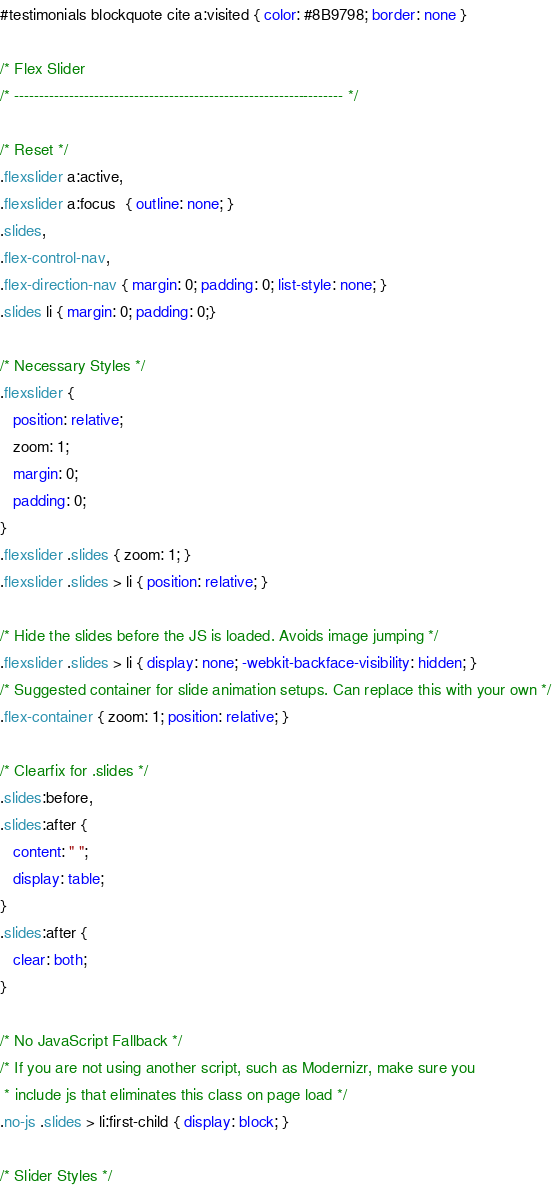<code> <loc_0><loc_0><loc_500><loc_500><_CSS_>#testimonials blockquote cite a:visited { color: #8B9798; border: none }

/* Flex Slider
/* ------------------------------------------------------------------ */

/* Reset */
.flexslider a:active,
.flexslider a:focus  { outline: none; }
.slides,
.flex-control-nav,
.flex-direction-nav { margin: 0; padding: 0; list-style: none; }
.slides li { margin: 0; padding: 0;}

/* Necessary Styles */
.flexslider {
   position: relative;
   zoom: 1;
   margin: 0;
   padding: 0;
}
.flexslider .slides { zoom: 1; }
.flexslider .slides > li { position: relative; }

/* Hide the slides before the JS is loaded. Avoids image jumping */
.flexslider .slides > li { display: none; -webkit-backface-visibility: hidden; }
/* Suggested container for slide animation setups. Can replace this with your own */
.flex-container { zoom: 1; position: relative; }

/* Clearfix for .slides */
.slides:before,
.slides:after {
   content: " ";
   display: table;
}
.slides:after {
   clear: both;
}

/* No JavaScript Fallback */
/* If you are not using another script, such as Modernizr, make sure you
 * include js that eliminates this class on page load */
.no-js .slides > li:first-child { display: block; }

/* Slider Styles */</code> 